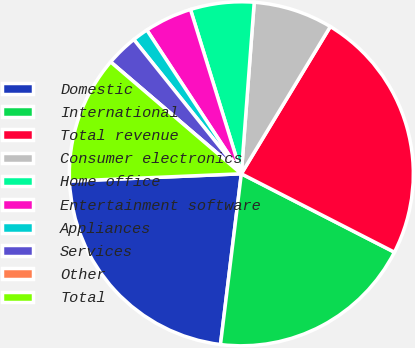Convert chart. <chart><loc_0><loc_0><loc_500><loc_500><pie_chart><fcel>Domestic<fcel>International<fcel>Total revenue<fcel>Consumer electronics<fcel>Home office<fcel>Entertainment software<fcel>Appliances<fcel>Services<fcel>Other<fcel>Total<nl><fcel>22.39%<fcel>19.4%<fcel>23.88%<fcel>7.46%<fcel>5.97%<fcel>4.48%<fcel>1.49%<fcel>2.99%<fcel>0.0%<fcel>11.94%<nl></chart> 